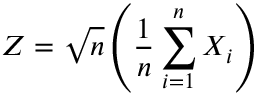Convert formula to latex. <formula><loc_0><loc_0><loc_500><loc_500>Z = { \sqrt { n } } \left ( { \frac { 1 } { n } } \sum _ { i = 1 } ^ { n } X _ { i } \right )</formula> 